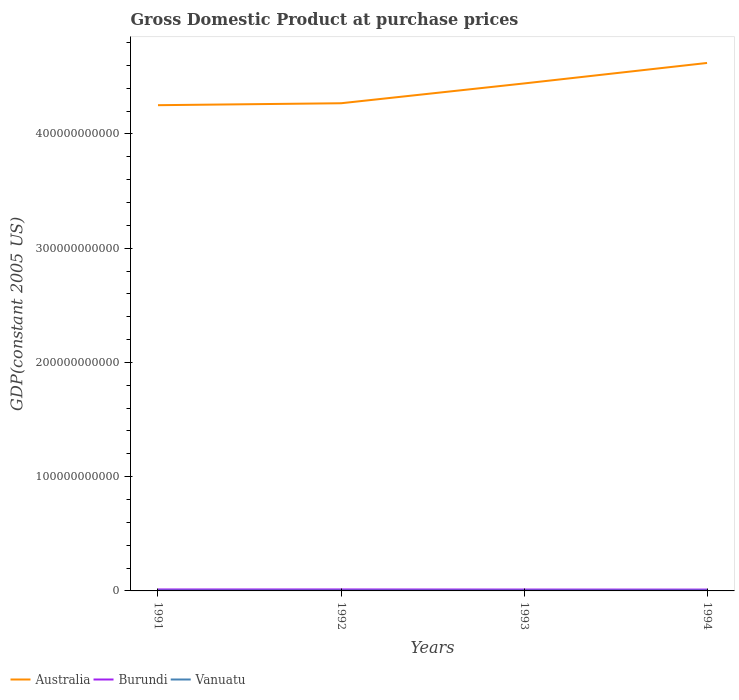Is the number of lines equal to the number of legend labels?
Make the answer very short. Yes. Across all years, what is the maximum GDP at purchase prices in Australia?
Keep it short and to the point. 4.25e+11. In which year was the GDP at purchase prices in Burundi maximum?
Offer a very short reply. 1994. What is the total GDP at purchase prices in Vanuatu in the graph?
Your answer should be very brief. -2.61e+07. What is the difference between the highest and the second highest GDP at purchase prices in Australia?
Your answer should be compact. 3.70e+1. How many years are there in the graph?
Ensure brevity in your answer.  4. What is the difference between two consecutive major ticks on the Y-axis?
Keep it short and to the point. 1.00e+11. How are the legend labels stacked?
Keep it short and to the point. Horizontal. What is the title of the graph?
Offer a terse response. Gross Domestic Product at purchase prices. What is the label or title of the Y-axis?
Keep it short and to the point. GDP(constant 2005 US). What is the GDP(constant 2005 US) in Australia in 1991?
Your response must be concise. 4.25e+11. What is the GDP(constant 2005 US) in Burundi in 1991?
Provide a short and direct response. 1.29e+09. What is the GDP(constant 2005 US) of Vanuatu in 1991?
Your answer should be compact. 2.79e+08. What is the GDP(constant 2005 US) in Australia in 1992?
Provide a short and direct response. 4.27e+11. What is the GDP(constant 2005 US) of Burundi in 1992?
Your answer should be very brief. 1.30e+09. What is the GDP(constant 2005 US) of Vanuatu in 1992?
Give a very brief answer. 2.86e+08. What is the GDP(constant 2005 US) of Australia in 1993?
Your response must be concise. 4.44e+11. What is the GDP(constant 2005 US) in Burundi in 1993?
Offer a very short reply. 1.22e+09. What is the GDP(constant 2005 US) of Vanuatu in 1993?
Give a very brief answer. 2.88e+08. What is the GDP(constant 2005 US) of Australia in 1994?
Your answer should be compact. 4.62e+11. What is the GDP(constant 2005 US) of Burundi in 1994?
Provide a short and direct response. 1.17e+09. What is the GDP(constant 2005 US) of Vanuatu in 1994?
Your answer should be compact. 3.14e+08. Across all years, what is the maximum GDP(constant 2005 US) in Australia?
Your response must be concise. 4.62e+11. Across all years, what is the maximum GDP(constant 2005 US) in Burundi?
Your answer should be compact. 1.30e+09. Across all years, what is the maximum GDP(constant 2005 US) in Vanuatu?
Make the answer very short. 3.14e+08. Across all years, what is the minimum GDP(constant 2005 US) of Australia?
Offer a very short reply. 4.25e+11. Across all years, what is the minimum GDP(constant 2005 US) in Burundi?
Make the answer very short. 1.17e+09. Across all years, what is the minimum GDP(constant 2005 US) of Vanuatu?
Provide a succinct answer. 2.79e+08. What is the total GDP(constant 2005 US) in Australia in the graph?
Your answer should be compact. 1.76e+12. What is the total GDP(constant 2005 US) in Burundi in the graph?
Your response must be concise. 4.97e+09. What is the total GDP(constant 2005 US) in Vanuatu in the graph?
Provide a short and direct response. 1.17e+09. What is the difference between the GDP(constant 2005 US) in Australia in 1991 and that in 1992?
Your answer should be very brief. -1.70e+09. What is the difference between the GDP(constant 2005 US) of Burundi in 1991 and that in 1992?
Your answer should be very brief. -1.30e+07. What is the difference between the GDP(constant 2005 US) in Vanuatu in 1991 and that in 1992?
Your response must be concise. -7.22e+06. What is the difference between the GDP(constant 2005 US) in Australia in 1991 and that in 1993?
Offer a terse response. -1.90e+1. What is the difference between the GDP(constant 2005 US) in Burundi in 1991 and that in 1993?
Make the answer very short. 6.80e+07. What is the difference between the GDP(constant 2005 US) in Vanuatu in 1991 and that in 1993?
Offer a terse response. -9.37e+06. What is the difference between the GDP(constant 2005 US) of Australia in 1991 and that in 1994?
Make the answer very short. -3.70e+1. What is the difference between the GDP(constant 2005 US) in Burundi in 1991 and that in 1994?
Your answer should be very brief. 1.15e+08. What is the difference between the GDP(constant 2005 US) of Vanuatu in 1991 and that in 1994?
Offer a very short reply. -3.55e+07. What is the difference between the GDP(constant 2005 US) in Australia in 1992 and that in 1993?
Offer a terse response. -1.73e+1. What is the difference between the GDP(constant 2005 US) of Burundi in 1992 and that in 1993?
Offer a very short reply. 8.10e+07. What is the difference between the GDP(constant 2005 US) of Vanuatu in 1992 and that in 1993?
Keep it short and to the point. -2.15e+06. What is the difference between the GDP(constant 2005 US) of Australia in 1992 and that in 1994?
Make the answer very short. -3.53e+1. What is the difference between the GDP(constant 2005 US) in Burundi in 1992 and that in 1994?
Offer a very short reply. 1.28e+08. What is the difference between the GDP(constant 2005 US) of Vanuatu in 1992 and that in 1994?
Offer a very short reply. -2.82e+07. What is the difference between the GDP(constant 2005 US) of Australia in 1993 and that in 1994?
Ensure brevity in your answer.  -1.79e+1. What is the difference between the GDP(constant 2005 US) in Burundi in 1993 and that in 1994?
Provide a succinct answer. 4.66e+07. What is the difference between the GDP(constant 2005 US) of Vanuatu in 1993 and that in 1994?
Offer a very short reply. -2.61e+07. What is the difference between the GDP(constant 2005 US) in Australia in 1991 and the GDP(constant 2005 US) in Burundi in 1992?
Keep it short and to the point. 4.24e+11. What is the difference between the GDP(constant 2005 US) in Australia in 1991 and the GDP(constant 2005 US) in Vanuatu in 1992?
Ensure brevity in your answer.  4.25e+11. What is the difference between the GDP(constant 2005 US) of Burundi in 1991 and the GDP(constant 2005 US) of Vanuatu in 1992?
Provide a succinct answer. 9.99e+08. What is the difference between the GDP(constant 2005 US) of Australia in 1991 and the GDP(constant 2005 US) of Burundi in 1993?
Provide a succinct answer. 4.24e+11. What is the difference between the GDP(constant 2005 US) in Australia in 1991 and the GDP(constant 2005 US) in Vanuatu in 1993?
Your answer should be compact. 4.25e+11. What is the difference between the GDP(constant 2005 US) in Burundi in 1991 and the GDP(constant 2005 US) in Vanuatu in 1993?
Your response must be concise. 9.97e+08. What is the difference between the GDP(constant 2005 US) of Australia in 1991 and the GDP(constant 2005 US) of Burundi in 1994?
Provide a succinct answer. 4.24e+11. What is the difference between the GDP(constant 2005 US) in Australia in 1991 and the GDP(constant 2005 US) in Vanuatu in 1994?
Ensure brevity in your answer.  4.25e+11. What is the difference between the GDP(constant 2005 US) in Burundi in 1991 and the GDP(constant 2005 US) in Vanuatu in 1994?
Offer a terse response. 9.71e+08. What is the difference between the GDP(constant 2005 US) in Australia in 1992 and the GDP(constant 2005 US) in Burundi in 1993?
Your answer should be compact. 4.26e+11. What is the difference between the GDP(constant 2005 US) in Australia in 1992 and the GDP(constant 2005 US) in Vanuatu in 1993?
Provide a succinct answer. 4.27e+11. What is the difference between the GDP(constant 2005 US) in Burundi in 1992 and the GDP(constant 2005 US) in Vanuatu in 1993?
Offer a terse response. 1.01e+09. What is the difference between the GDP(constant 2005 US) in Australia in 1992 and the GDP(constant 2005 US) in Burundi in 1994?
Provide a succinct answer. 4.26e+11. What is the difference between the GDP(constant 2005 US) in Australia in 1992 and the GDP(constant 2005 US) in Vanuatu in 1994?
Your answer should be compact. 4.27e+11. What is the difference between the GDP(constant 2005 US) in Burundi in 1992 and the GDP(constant 2005 US) in Vanuatu in 1994?
Offer a terse response. 9.84e+08. What is the difference between the GDP(constant 2005 US) in Australia in 1993 and the GDP(constant 2005 US) in Burundi in 1994?
Offer a terse response. 4.43e+11. What is the difference between the GDP(constant 2005 US) of Australia in 1993 and the GDP(constant 2005 US) of Vanuatu in 1994?
Your response must be concise. 4.44e+11. What is the difference between the GDP(constant 2005 US) in Burundi in 1993 and the GDP(constant 2005 US) in Vanuatu in 1994?
Provide a short and direct response. 9.03e+08. What is the average GDP(constant 2005 US) of Australia per year?
Give a very brief answer. 4.40e+11. What is the average GDP(constant 2005 US) of Burundi per year?
Ensure brevity in your answer.  1.24e+09. What is the average GDP(constant 2005 US) of Vanuatu per year?
Ensure brevity in your answer.  2.92e+08. In the year 1991, what is the difference between the GDP(constant 2005 US) in Australia and GDP(constant 2005 US) in Burundi?
Offer a terse response. 4.24e+11. In the year 1991, what is the difference between the GDP(constant 2005 US) in Australia and GDP(constant 2005 US) in Vanuatu?
Provide a short and direct response. 4.25e+11. In the year 1991, what is the difference between the GDP(constant 2005 US) of Burundi and GDP(constant 2005 US) of Vanuatu?
Offer a terse response. 1.01e+09. In the year 1992, what is the difference between the GDP(constant 2005 US) of Australia and GDP(constant 2005 US) of Burundi?
Give a very brief answer. 4.26e+11. In the year 1992, what is the difference between the GDP(constant 2005 US) in Australia and GDP(constant 2005 US) in Vanuatu?
Make the answer very short. 4.27e+11. In the year 1992, what is the difference between the GDP(constant 2005 US) of Burundi and GDP(constant 2005 US) of Vanuatu?
Keep it short and to the point. 1.01e+09. In the year 1993, what is the difference between the GDP(constant 2005 US) in Australia and GDP(constant 2005 US) in Burundi?
Provide a succinct answer. 4.43e+11. In the year 1993, what is the difference between the GDP(constant 2005 US) in Australia and GDP(constant 2005 US) in Vanuatu?
Provide a short and direct response. 4.44e+11. In the year 1993, what is the difference between the GDP(constant 2005 US) in Burundi and GDP(constant 2005 US) in Vanuatu?
Provide a succinct answer. 9.29e+08. In the year 1994, what is the difference between the GDP(constant 2005 US) in Australia and GDP(constant 2005 US) in Burundi?
Give a very brief answer. 4.61e+11. In the year 1994, what is the difference between the GDP(constant 2005 US) of Australia and GDP(constant 2005 US) of Vanuatu?
Give a very brief answer. 4.62e+11. In the year 1994, what is the difference between the GDP(constant 2005 US) in Burundi and GDP(constant 2005 US) in Vanuatu?
Keep it short and to the point. 8.56e+08. What is the ratio of the GDP(constant 2005 US) in Australia in 1991 to that in 1992?
Provide a succinct answer. 1. What is the ratio of the GDP(constant 2005 US) of Vanuatu in 1991 to that in 1992?
Make the answer very short. 0.97. What is the ratio of the GDP(constant 2005 US) in Australia in 1991 to that in 1993?
Ensure brevity in your answer.  0.96. What is the ratio of the GDP(constant 2005 US) of Burundi in 1991 to that in 1993?
Your response must be concise. 1.06. What is the ratio of the GDP(constant 2005 US) of Vanuatu in 1991 to that in 1993?
Ensure brevity in your answer.  0.97. What is the ratio of the GDP(constant 2005 US) in Burundi in 1991 to that in 1994?
Make the answer very short. 1.1. What is the ratio of the GDP(constant 2005 US) of Vanuatu in 1991 to that in 1994?
Offer a terse response. 0.89. What is the ratio of the GDP(constant 2005 US) in Australia in 1992 to that in 1993?
Your response must be concise. 0.96. What is the ratio of the GDP(constant 2005 US) of Burundi in 1992 to that in 1993?
Your answer should be compact. 1.07. What is the ratio of the GDP(constant 2005 US) in Australia in 1992 to that in 1994?
Provide a short and direct response. 0.92. What is the ratio of the GDP(constant 2005 US) in Burundi in 1992 to that in 1994?
Offer a terse response. 1.11. What is the ratio of the GDP(constant 2005 US) of Vanuatu in 1992 to that in 1994?
Give a very brief answer. 0.91. What is the ratio of the GDP(constant 2005 US) in Australia in 1993 to that in 1994?
Your answer should be compact. 0.96. What is the ratio of the GDP(constant 2005 US) of Burundi in 1993 to that in 1994?
Provide a succinct answer. 1.04. What is the ratio of the GDP(constant 2005 US) of Vanuatu in 1993 to that in 1994?
Offer a very short reply. 0.92. What is the difference between the highest and the second highest GDP(constant 2005 US) in Australia?
Your answer should be compact. 1.79e+1. What is the difference between the highest and the second highest GDP(constant 2005 US) in Burundi?
Provide a short and direct response. 1.30e+07. What is the difference between the highest and the second highest GDP(constant 2005 US) of Vanuatu?
Offer a very short reply. 2.61e+07. What is the difference between the highest and the lowest GDP(constant 2005 US) in Australia?
Offer a terse response. 3.70e+1. What is the difference between the highest and the lowest GDP(constant 2005 US) of Burundi?
Offer a very short reply. 1.28e+08. What is the difference between the highest and the lowest GDP(constant 2005 US) of Vanuatu?
Ensure brevity in your answer.  3.55e+07. 